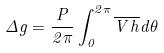<formula> <loc_0><loc_0><loc_500><loc_500>\Delta g = \frac { P } { 2 \pi } \int _ { 0 } ^ { 2 \pi } \overline { V } \overline { h } d \theta</formula> 